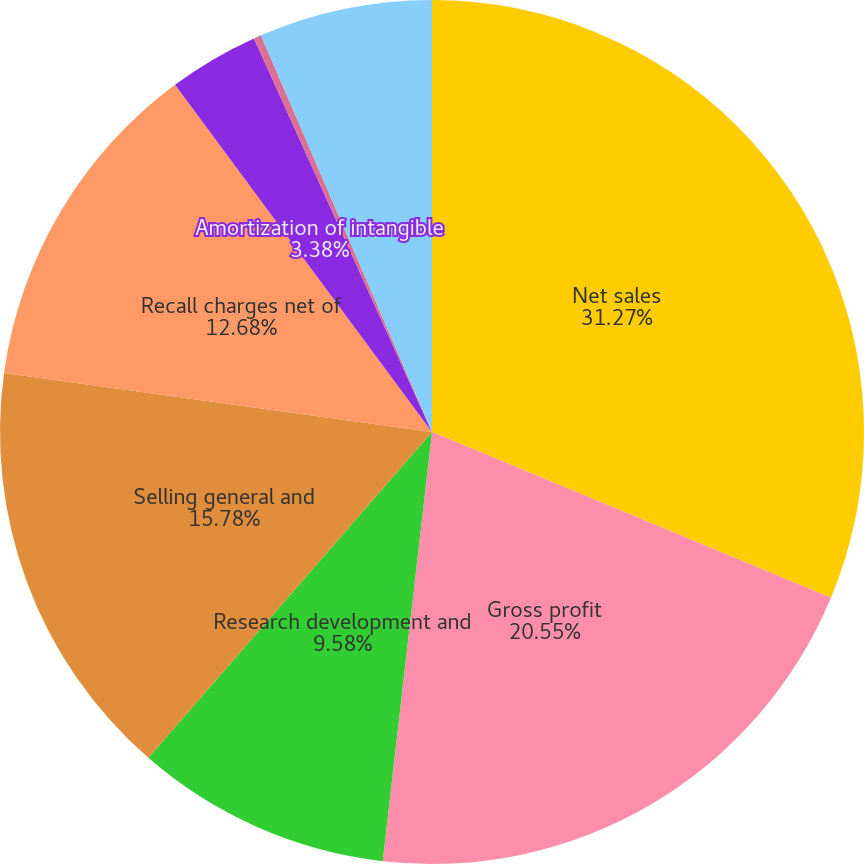Convert chart to OTSL. <chart><loc_0><loc_0><loc_500><loc_500><pie_chart><fcel>Net sales<fcel>Gross profit<fcel>Research development and<fcel>Selling general and<fcel>Recall charges net of<fcel>Amortization of intangible<fcel>Other income (expense) net<fcel>Net earnings<nl><fcel>31.27%<fcel>20.55%<fcel>9.58%<fcel>15.78%<fcel>12.68%<fcel>3.38%<fcel>0.28%<fcel>6.48%<nl></chart> 